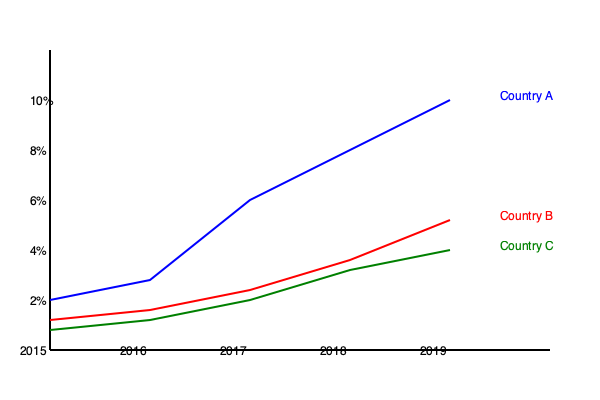Based on the GDP growth rates shown in the graph, which country demonstrates the strongest evidence of free-market policies leading to economic growth, and why? To answer this question, we need to analyze the GDP growth rates of the three countries:

1. Country A (blue line):
   - Starts at about 2% growth in 2015
   - Shows a consistent upward trend
   - Reaches about 10% growth by 2019
   - Demonstrates the steepest and most consistent growth

2. Country B (red line):
   - Starts at about 1.5% growth in 2015
   - Shows a gradual upward trend
   - Reaches about 5% growth by 2019
   - Demonstrates moderate, steady growth

3. Country C (green line):
   - Starts at about 1% growth in 2015
   - Shows a slight upward trend
   - Reaches about 4% growth by 2019
   - Demonstrates the slowest growth among the three

From a free-market perspective, Country A shows the strongest evidence of policies leading to economic growth because:

1. Rapid growth: The steep increase in GDP growth rate suggests that the country's economic policies are effectively stimulating production and investment.

2. Consistency: The steady upward trend indicates that the growth is not just a short-term fluctuation but a sustained improvement in economic performance.

3. Outperformance: Country A's growth rate significantly outpaces that of Countries B and C, suggesting that its policies are more effective in promoting economic expansion.

4. Magnitude of change: The increase from 2% to 10% over five years is substantial, indicating that the country's economic framework is highly conducive to growth.

Free-market advocates often argue that less government intervention and more economic freedom lead to higher growth rates. Country A's performance aligns with this view, as its rapid and consistent growth suggests a dynamic economy responding to market forces rather than being constrained by excessive regulation or state control.
Answer: Country A, due to its rapid, consistent, and superior GDP growth rate. 